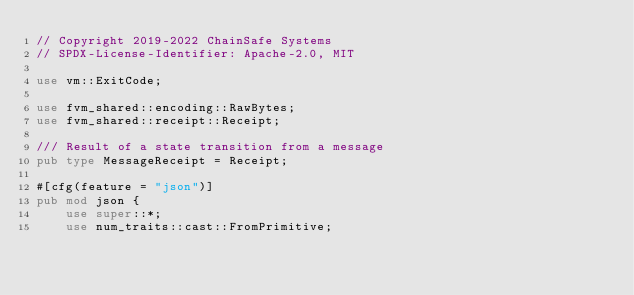<code> <loc_0><loc_0><loc_500><loc_500><_Rust_>// Copyright 2019-2022 ChainSafe Systems
// SPDX-License-Identifier: Apache-2.0, MIT

use vm::ExitCode;

use fvm_shared::encoding::RawBytes;
use fvm_shared::receipt::Receipt;

/// Result of a state transition from a message
pub type MessageReceipt = Receipt;

#[cfg(feature = "json")]
pub mod json {
    use super::*;
    use num_traits::cast::FromPrimitive;</code> 